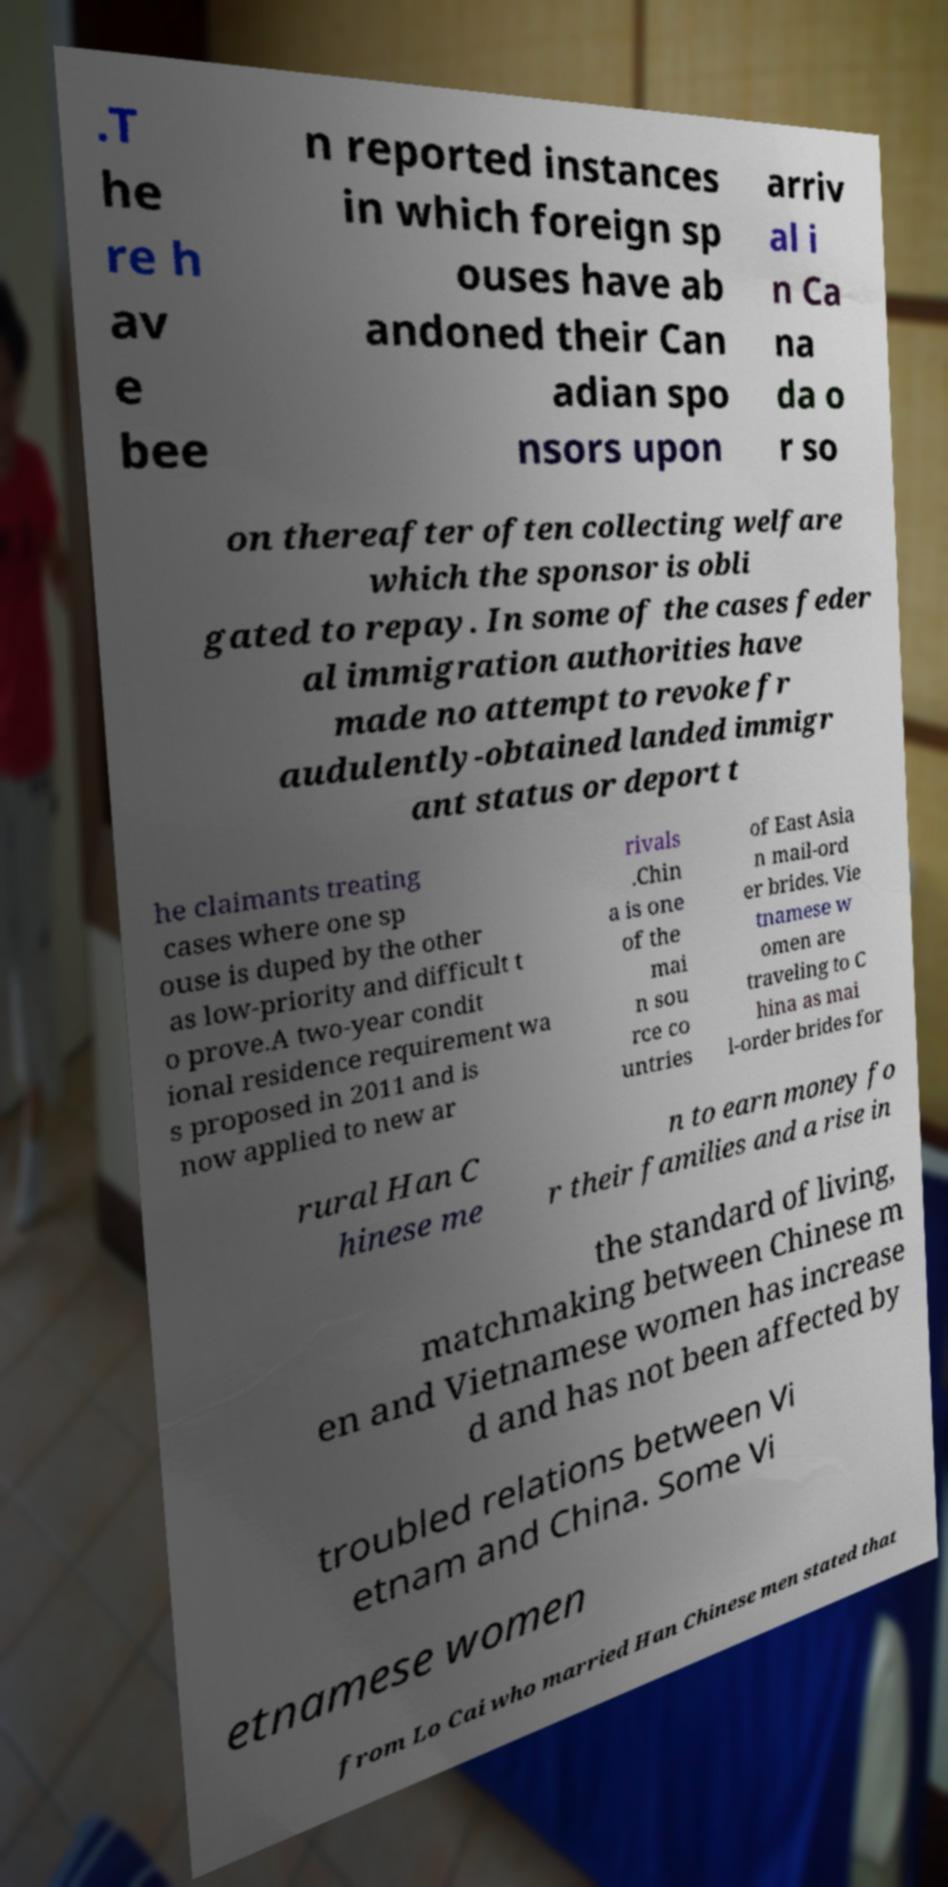There's text embedded in this image that I need extracted. Can you transcribe it verbatim? .T he re h av e bee n reported instances in which foreign sp ouses have ab andoned their Can adian spo nsors upon arriv al i n Ca na da o r so on thereafter often collecting welfare which the sponsor is obli gated to repay. In some of the cases feder al immigration authorities have made no attempt to revoke fr audulently-obtained landed immigr ant status or deport t he claimants treating cases where one sp ouse is duped by the other as low-priority and difficult t o prove.A two-year condit ional residence requirement wa s proposed in 2011 and is now applied to new ar rivals .Chin a is one of the mai n sou rce co untries of East Asia n mail-ord er brides. Vie tnamese w omen are traveling to C hina as mai l-order brides for rural Han C hinese me n to earn money fo r their families and a rise in the standard of living, matchmaking between Chinese m en and Vietnamese women has increase d and has not been affected by troubled relations between Vi etnam and China. Some Vi etnamese women from Lo Cai who married Han Chinese men stated that 